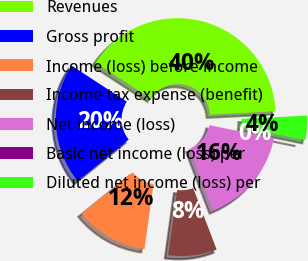<chart> <loc_0><loc_0><loc_500><loc_500><pie_chart><fcel>Revenues<fcel>Gross profit<fcel>Income (loss) before income<fcel>Income tax expense (benefit)<fcel>Net income (loss)<fcel>Basic net income (loss) per<fcel>Diluted net income (loss) per<nl><fcel>39.99%<fcel>20.0%<fcel>12.0%<fcel>8.0%<fcel>16.0%<fcel>0.0%<fcel>4.0%<nl></chart> 